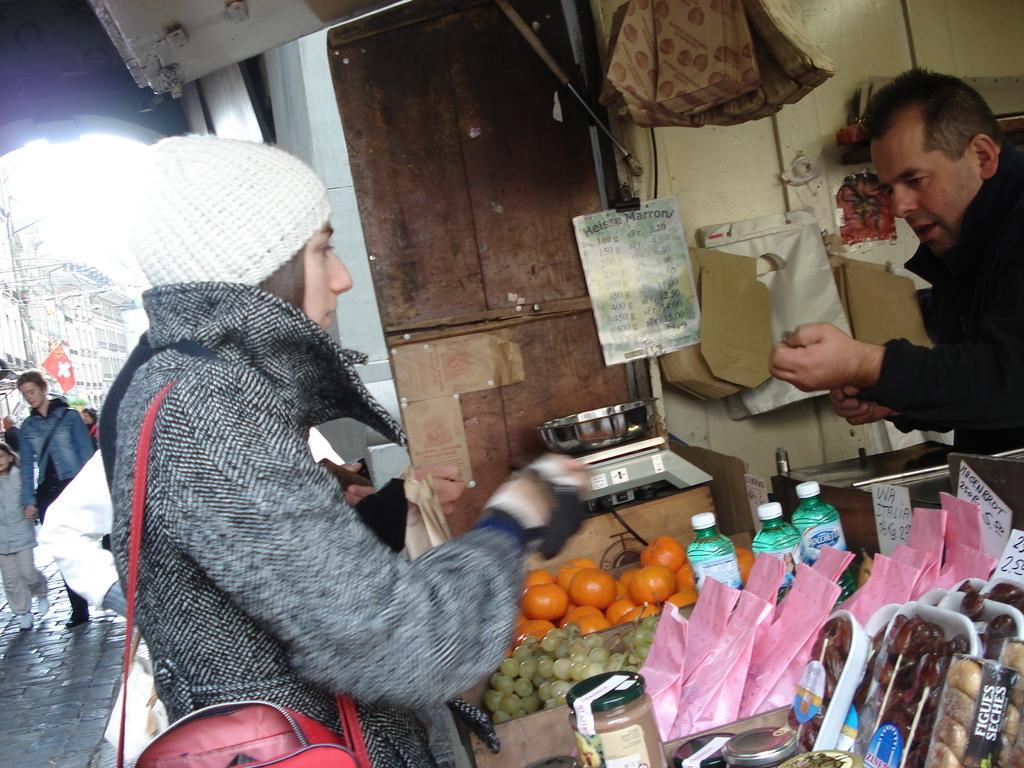Can you describe this image briefly? In the image there is a woman standing in front of a store, there are some fruits and other food items kept in front of her along with the price tags and behind the food items there is a man and there is a weighing machine, behind that there is a wooden wall and there are some bags attached to the wall and in the background of the woman there are some other people walking on the path. 